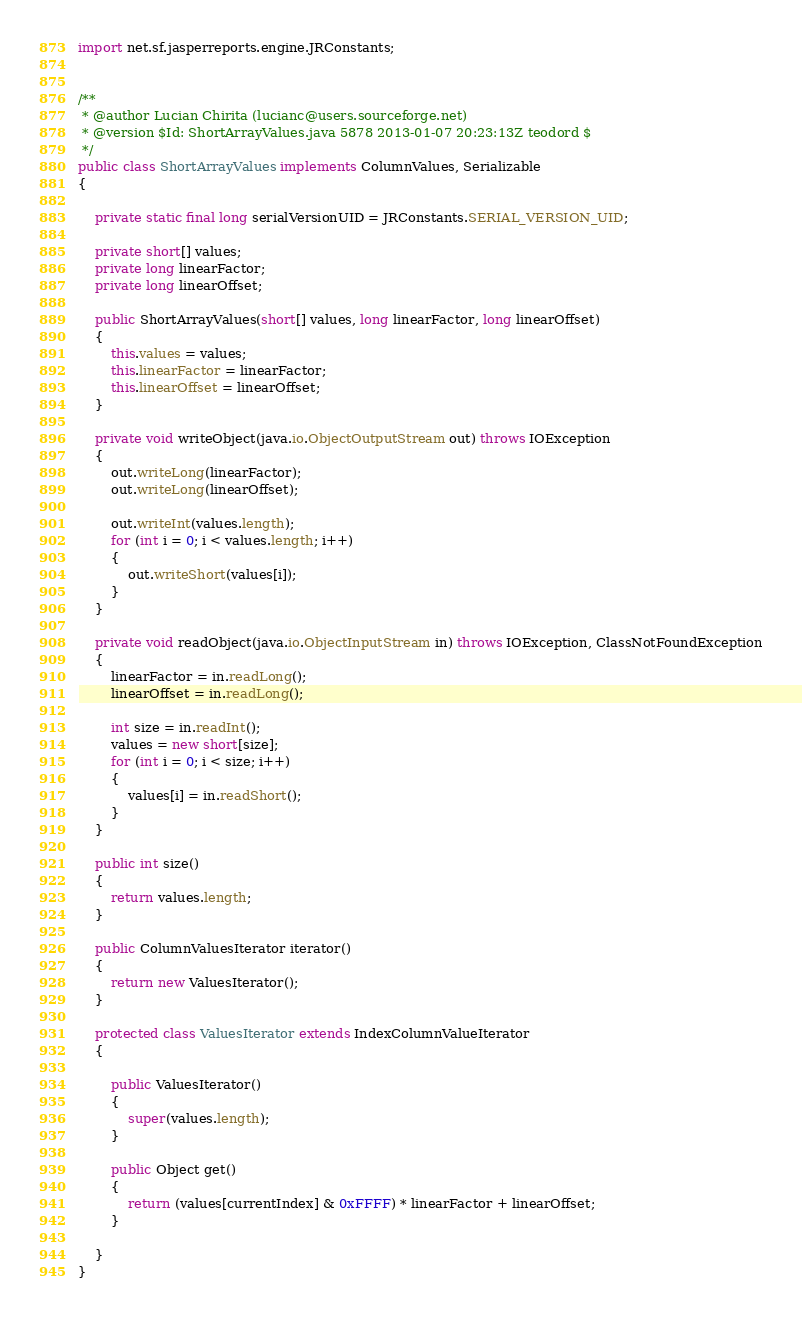Convert code to text. <code><loc_0><loc_0><loc_500><loc_500><_Java_>
import net.sf.jasperreports.engine.JRConstants;


/**
 * @author Lucian Chirita (lucianc@users.sourceforge.net)
 * @version $Id: ShortArrayValues.java 5878 2013-01-07 20:23:13Z teodord $
 */
public class ShortArrayValues implements ColumnValues, Serializable
{

	private static final long serialVersionUID = JRConstants.SERIAL_VERSION_UID;

	private short[] values;
	private long linearFactor;
	private long linearOffset;
	
	public ShortArrayValues(short[] values, long linearFactor, long linearOffset)
	{
		this.values = values;
		this.linearFactor = linearFactor;
		this.linearOffset = linearOffset;
	}
	
	private void writeObject(java.io.ObjectOutputStream out) throws IOException
	{
		out.writeLong(linearFactor);
		out.writeLong(linearOffset);
		
		out.writeInt(values.length);
		for (int i = 0; i < values.length; i++)
		{
			out.writeShort(values[i]);
		}
	}
	
	private void readObject(java.io.ObjectInputStream in) throws IOException, ClassNotFoundException
	{
		linearFactor = in.readLong();
		linearOffset = in.readLong();
		
		int size = in.readInt();
		values = new short[size];
		for (int i = 0; i < size; i++)
		{
			values[i] = in.readShort();
		}
	}
	
	public int size()
	{
		return values.length;
	}

	public ColumnValuesIterator iterator()
	{
		return new ValuesIterator();
	}

	protected class ValuesIterator extends IndexColumnValueIterator
	{

		public ValuesIterator()
		{
			super(values.length);
		}

		public Object get()
		{
			return (values[currentIndex] & 0xFFFF) * linearFactor + linearOffset;
		}
		
	}
}
</code> 